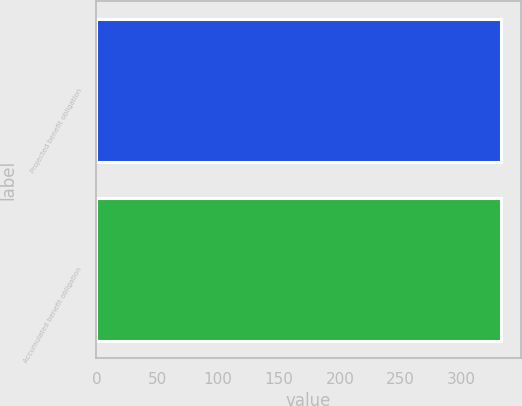<chart> <loc_0><loc_0><loc_500><loc_500><bar_chart><fcel>Projected benefit obligation<fcel>Accumulated benefit obligation<nl><fcel>332<fcel>332.1<nl></chart> 